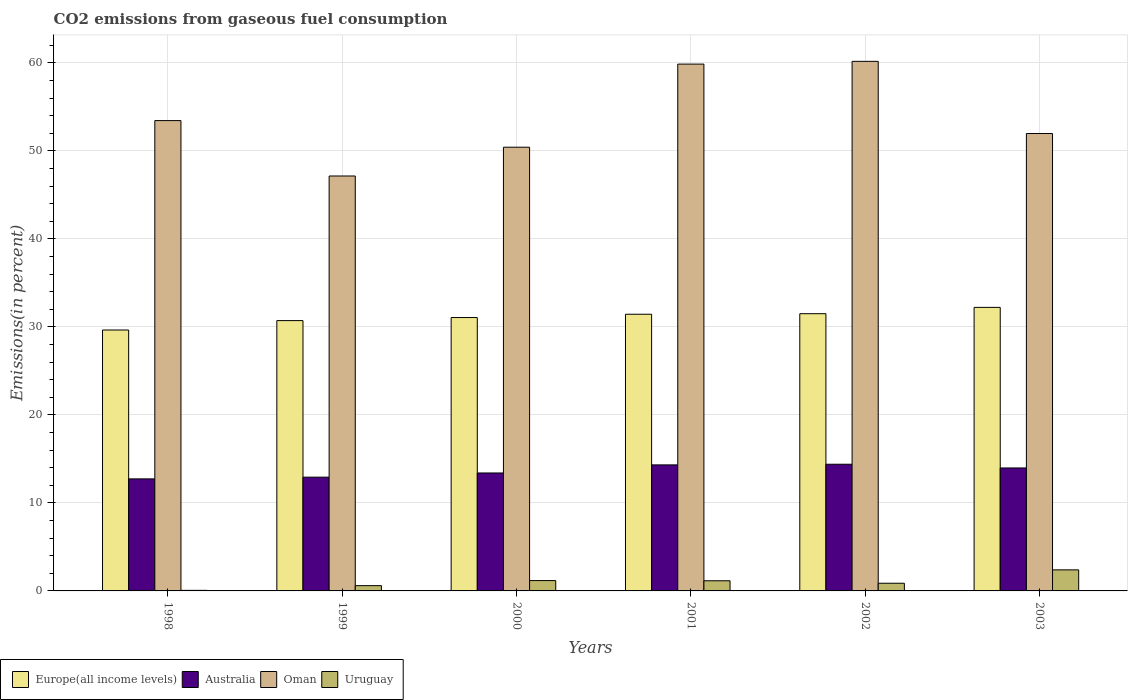What is the total CO2 emitted in Uruguay in 1998?
Offer a very short reply. 0.06. Across all years, what is the maximum total CO2 emitted in Uruguay?
Give a very brief answer. 2.39. Across all years, what is the minimum total CO2 emitted in Europe(all income levels)?
Your answer should be very brief. 29.64. In which year was the total CO2 emitted in Oman maximum?
Offer a terse response. 2002. What is the total total CO2 emitted in Oman in the graph?
Give a very brief answer. 322.96. What is the difference between the total CO2 emitted in Australia in 2001 and that in 2003?
Give a very brief answer. 0.35. What is the difference between the total CO2 emitted in Europe(all income levels) in 1998 and the total CO2 emitted in Uruguay in 2002?
Ensure brevity in your answer.  28.77. What is the average total CO2 emitted in Europe(all income levels) per year?
Your answer should be compact. 31.09. In the year 2001, what is the difference between the total CO2 emitted in Europe(all income levels) and total CO2 emitted in Uruguay?
Keep it short and to the point. 30.28. In how many years, is the total CO2 emitted in Oman greater than 38 %?
Ensure brevity in your answer.  6. What is the ratio of the total CO2 emitted in Australia in 2001 to that in 2003?
Ensure brevity in your answer.  1.03. What is the difference between the highest and the second highest total CO2 emitted in Uruguay?
Keep it short and to the point. 1.22. What is the difference between the highest and the lowest total CO2 emitted in Oman?
Provide a succinct answer. 13.02. Is the sum of the total CO2 emitted in Oman in 1999 and 2003 greater than the maximum total CO2 emitted in Europe(all income levels) across all years?
Offer a very short reply. Yes. Is it the case that in every year, the sum of the total CO2 emitted in Oman and total CO2 emitted in Europe(all income levels) is greater than the sum of total CO2 emitted in Australia and total CO2 emitted in Uruguay?
Your answer should be compact. Yes. What does the 1st bar from the left in 2003 represents?
Provide a short and direct response. Europe(all income levels). What does the 3rd bar from the right in 2002 represents?
Make the answer very short. Australia. What is the difference between two consecutive major ticks on the Y-axis?
Provide a short and direct response. 10. Are the values on the major ticks of Y-axis written in scientific E-notation?
Your answer should be compact. No. Does the graph contain any zero values?
Give a very brief answer. No. Where does the legend appear in the graph?
Make the answer very short. Bottom left. How many legend labels are there?
Provide a short and direct response. 4. What is the title of the graph?
Offer a very short reply. CO2 emissions from gaseous fuel consumption. What is the label or title of the X-axis?
Offer a terse response. Years. What is the label or title of the Y-axis?
Give a very brief answer. Emissions(in percent). What is the Emissions(in percent) in Europe(all income levels) in 1998?
Make the answer very short. 29.64. What is the Emissions(in percent) of Australia in 1998?
Give a very brief answer. 12.73. What is the Emissions(in percent) in Oman in 1998?
Your answer should be very brief. 53.43. What is the Emissions(in percent) of Uruguay in 1998?
Offer a very short reply. 0.06. What is the Emissions(in percent) in Europe(all income levels) in 1999?
Your answer should be very brief. 30.71. What is the Emissions(in percent) in Australia in 1999?
Provide a succinct answer. 12.92. What is the Emissions(in percent) of Oman in 1999?
Your response must be concise. 47.14. What is the Emissions(in percent) in Uruguay in 1999?
Make the answer very short. 0.6. What is the Emissions(in percent) in Europe(all income levels) in 2000?
Provide a short and direct response. 31.06. What is the Emissions(in percent) of Australia in 2000?
Offer a terse response. 13.4. What is the Emissions(in percent) in Oman in 2000?
Your answer should be compact. 50.41. What is the Emissions(in percent) of Uruguay in 2000?
Provide a short and direct response. 1.17. What is the Emissions(in percent) of Europe(all income levels) in 2001?
Ensure brevity in your answer.  31.43. What is the Emissions(in percent) of Australia in 2001?
Keep it short and to the point. 14.32. What is the Emissions(in percent) in Oman in 2001?
Make the answer very short. 59.85. What is the Emissions(in percent) of Uruguay in 2001?
Ensure brevity in your answer.  1.15. What is the Emissions(in percent) of Europe(all income levels) in 2002?
Make the answer very short. 31.5. What is the Emissions(in percent) in Australia in 2002?
Offer a terse response. 14.39. What is the Emissions(in percent) in Oman in 2002?
Give a very brief answer. 60.16. What is the Emissions(in percent) in Uruguay in 2002?
Your answer should be very brief. 0.87. What is the Emissions(in percent) in Europe(all income levels) in 2003?
Your answer should be compact. 32.21. What is the Emissions(in percent) of Australia in 2003?
Your answer should be compact. 13.97. What is the Emissions(in percent) in Oman in 2003?
Your response must be concise. 51.96. What is the Emissions(in percent) in Uruguay in 2003?
Offer a very short reply. 2.39. Across all years, what is the maximum Emissions(in percent) in Europe(all income levels)?
Offer a very short reply. 32.21. Across all years, what is the maximum Emissions(in percent) in Australia?
Give a very brief answer. 14.39. Across all years, what is the maximum Emissions(in percent) of Oman?
Provide a short and direct response. 60.16. Across all years, what is the maximum Emissions(in percent) in Uruguay?
Ensure brevity in your answer.  2.39. Across all years, what is the minimum Emissions(in percent) of Europe(all income levels)?
Your answer should be very brief. 29.64. Across all years, what is the minimum Emissions(in percent) in Australia?
Provide a short and direct response. 12.73. Across all years, what is the minimum Emissions(in percent) of Oman?
Offer a terse response. 47.14. Across all years, what is the minimum Emissions(in percent) of Uruguay?
Give a very brief answer. 0.06. What is the total Emissions(in percent) of Europe(all income levels) in the graph?
Your answer should be very brief. 186.55. What is the total Emissions(in percent) of Australia in the graph?
Provide a short and direct response. 81.73. What is the total Emissions(in percent) of Oman in the graph?
Make the answer very short. 322.96. What is the total Emissions(in percent) in Uruguay in the graph?
Provide a short and direct response. 6.26. What is the difference between the Emissions(in percent) in Europe(all income levels) in 1998 and that in 1999?
Your answer should be compact. -1.07. What is the difference between the Emissions(in percent) in Australia in 1998 and that in 1999?
Provide a succinct answer. -0.19. What is the difference between the Emissions(in percent) of Oman in 1998 and that in 1999?
Give a very brief answer. 6.29. What is the difference between the Emissions(in percent) in Uruguay in 1998 and that in 1999?
Provide a succinct answer. -0.54. What is the difference between the Emissions(in percent) in Europe(all income levels) in 1998 and that in 2000?
Keep it short and to the point. -1.42. What is the difference between the Emissions(in percent) of Australia in 1998 and that in 2000?
Offer a terse response. -0.67. What is the difference between the Emissions(in percent) in Oman in 1998 and that in 2000?
Provide a short and direct response. 3.02. What is the difference between the Emissions(in percent) of Uruguay in 1998 and that in 2000?
Provide a succinct answer. -1.11. What is the difference between the Emissions(in percent) of Europe(all income levels) in 1998 and that in 2001?
Offer a very short reply. -1.79. What is the difference between the Emissions(in percent) of Australia in 1998 and that in 2001?
Provide a succinct answer. -1.59. What is the difference between the Emissions(in percent) in Oman in 1998 and that in 2001?
Provide a short and direct response. -6.42. What is the difference between the Emissions(in percent) of Uruguay in 1998 and that in 2001?
Provide a short and direct response. -1.09. What is the difference between the Emissions(in percent) of Europe(all income levels) in 1998 and that in 2002?
Your answer should be compact. -1.85. What is the difference between the Emissions(in percent) in Australia in 1998 and that in 2002?
Offer a terse response. -1.66. What is the difference between the Emissions(in percent) in Oman in 1998 and that in 2002?
Offer a very short reply. -6.73. What is the difference between the Emissions(in percent) in Uruguay in 1998 and that in 2002?
Offer a very short reply. -0.81. What is the difference between the Emissions(in percent) of Europe(all income levels) in 1998 and that in 2003?
Offer a terse response. -2.57. What is the difference between the Emissions(in percent) of Australia in 1998 and that in 2003?
Your answer should be compact. -1.24. What is the difference between the Emissions(in percent) in Oman in 1998 and that in 2003?
Give a very brief answer. 1.47. What is the difference between the Emissions(in percent) in Uruguay in 1998 and that in 2003?
Give a very brief answer. -2.33. What is the difference between the Emissions(in percent) in Europe(all income levels) in 1999 and that in 2000?
Give a very brief answer. -0.35. What is the difference between the Emissions(in percent) in Australia in 1999 and that in 2000?
Ensure brevity in your answer.  -0.48. What is the difference between the Emissions(in percent) in Oman in 1999 and that in 2000?
Give a very brief answer. -3.27. What is the difference between the Emissions(in percent) of Uruguay in 1999 and that in 2000?
Ensure brevity in your answer.  -0.58. What is the difference between the Emissions(in percent) in Europe(all income levels) in 1999 and that in 2001?
Make the answer very short. -0.72. What is the difference between the Emissions(in percent) of Australia in 1999 and that in 2001?
Provide a short and direct response. -1.4. What is the difference between the Emissions(in percent) of Oman in 1999 and that in 2001?
Give a very brief answer. -12.71. What is the difference between the Emissions(in percent) of Uruguay in 1999 and that in 2001?
Keep it short and to the point. -0.55. What is the difference between the Emissions(in percent) in Europe(all income levels) in 1999 and that in 2002?
Give a very brief answer. -0.78. What is the difference between the Emissions(in percent) of Australia in 1999 and that in 2002?
Provide a short and direct response. -1.47. What is the difference between the Emissions(in percent) of Oman in 1999 and that in 2002?
Offer a very short reply. -13.02. What is the difference between the Emissions(in percent) of Uruguay in 1999 and that in 2002?
Offer a very short reply. -0.27. What is the difference between the Emissions(in percent) in Europe(all income levels) in 1999 and that in 2003?
Your answer should be compact. -1.5. What is the difference between the Emissions(in percent) in Australia in 1999 and that in 2003?
Ensure brevity in your answer.  -1.05. What is the difference between the Emissions(in percent) in Oman in 1999 and that in 2003?
Offer a very short reply. -4.82. What is the difference between the Emissions(in percent) in Uruguay in 1999 and that in 2003?
Provide a short and direct response. -1.79. What is the difference between the Emissions(in percent) in Europe(all income levels) in 2000 and that in 2001?
Your response must be concise. -0.37. What is the difference between the Emissions(in percent) of Australia in 2000 and that in 2001?
Your response must be concise. -0.92. What is the difference between the Emissions(in percent) of Oman in 2000 and that in 2001?
Offer a very short reply. -9.44. What is the difference between the Emissions(in percent) in Uruguay in 2000 and that in 2001?
Keep it short and to the point. 0.02. What is the difference between the Emissions(in percent) in Europe(all income levels) in 2000 and that in 2002?
Offer a terse response. -0.44. What is the difference between the Emissions(in percent) of Australia in 2000 and that in 2002?
Your response must be concise. -0.99. What is the difference between the Emissions(in percent) of Oman in 2000 and that in 2002?
Your answer should be very brief. -9.75. What is the difference between the Emissions(in percent) of Uruguay in 2000 and that in 2002?
Give a very brief answer. 0.3. What is the difference between the Emissions(in percent) of Europe(all income levels) in 2000 and that in 2003?
Ensure brevity in your answer.  -1.15. What is the difference between the Emissions(in percent) in Australia in 2000 and that in 2003?
Ensure brevity in your answer.  -0.57. What is the difference between the Emissions(in percent) in Oman in 2000 and that in 2003?
Give a very brief answer. -1.55. What is the difference between the Emissions(in percent) of Uruguay in 2000 and that in 2003?
Provide a succinct answer. -1.22. What is the difference between the Emissions(in percent) in Europe(all income levels) in 2001 and that in 2002?
Ensure brevity in your answer.  -0.06. What is the difference between the Emissions(in percent) in Australia in 2001 and that in 2002?
Your response must be concise. -0.07. What is the difference between the Emissions(in percent) in Oman in 2001 and that in 2002?
Ensure brevity in your answer.  -0.31. What is the difference between the Emissions(in percent) of Uruguay in 2001 and that in 2002?
Ensure brevity in your answer.  0.28. What is the difference between the Emissions(in percent) of Europe(all income levels) in 2001 and that in 2003?
Give a very brief answer. -0.78. What is the difference between the Emissions(in percent) of Australia in 2001 and that in 2003?
Give a very brief answer. 0.35. What is the difference between the Emissions(in percent) of Oman in 2001 and that in 2003?
Your response must be concise. 7.89. What is the difference between the Emissions(in percent) in Uruguay in 2001 and that in 2003?
Your answer should be very brief. -1.24. What is the difference between the Emissions(in percent) in Europe(all income levels) in 2002 and that in 2003?
Keep it short and to the point. -0.72. What is the difference between the Emissions(in percent) of Australia in 2002 and that in 2003?
Keep it short and to the point. 0.42. What is the difference between the Emissions(in percent) in Oman in 2002 and that in 2003?
Provide a succinct answer. 8.2. What is the difference between the Emissions(in percent) of Uruguay in 2002 and that in 2003?
Provide a succinct answer. -1.52. What is the difference between the Emissions(in percent) of Europe(all income levels) in 1998 and the Emissions(in percent) of Australia in 1999?
Offer a very short reply. 16.72. What is the difference between the Emissions(in percent) of Europe(all income levels) in 1998 and the Emissions(in percent) of Oman in 1999?
Make the answer very short. -17.5. What is the difference between the Emissions(in percent) of Europe(all income levels) in 1998 and the Emissions(in percent) of Uruguay in 1999?
Give a very brief answer. 29.04. What is the difference between the Emissions(in percent) of Australia in 1998 and the Emissions(in percent) of Oman in 1999?
Your response must be concise. -34.41. What is the difference between the Emissions(in percent) of Australia in 1998 and the Emissions(in percent) of Uruguay in 1999?
Keep it short and to the point. 12.13. What is the difference between the Emissions(in percent) of Oman in 1998 and the Emissions(in percent) of Uruguay in 1999?
Your answer should be very brief. 52.83. What is the difference between the Emissions(in percent) in Europe(all income levels) in 1998 and the Emissions(in percent) in Australia in 2000?
Offer a terse response. 16.24. What is the difference between the Emissions(in percent) in Europe(all income levels) in 1998 and the Emissions(in percent) in Oman in 2000?
Ensure brevity in your answer.  -20.77. What is the difference between the Emissions(in percent) of Europe(all income levels) in 1998 and the Emissions(in percent) of Uruguay in 2000?
Keep it short and to the point. 28.47. What is the difference between the Emissions(in percent) of Australia in 1998 and the Emissions(in percent) of Oman in 2000?
Provide a short and direct response. -37.68. What is the difference between the Emissions(in percent) in Australia in 1998 and the Emissions(in percent) in Uruguay in 2000?
Your answer should be very brief. 11.55. What is the difference between the Emissions(in percent) of Oman in 1998 and the Emissions(in percent) of Uruguay in 2000?
Give a very brief answer. 52.26. What is the difference between the Emissions(in percent) of Europe(all income levels) in 1998 and the Emissions(in percent) of Australia in 2001?
Your answer should be very brief. 15.32. What is the difference between the Emissions(in percent) of Europe(all income levels) in 1998 and the Emissions(in percent) of Oman in 2001?
Ensure brevity in your answer.  -30.21. What is the difference between the Emissions(in percent) in Europe(all income levels) in 1998 and the Emissions(in percent) in Uruguay in 2001?
Your response must be concise. 28.49. What is the difference between the Emissions(in percent) of Australia in 1998 and the Emissions(in percent) of Oman in 2001?
Ensure brevity in your answer.  -47.12. What is the difference between the Emissions(in percent) of Australia in 1998 and the Emissions(in percent) of Uruguay in 2001?
Offer a terse response. 11.58. What is the difference between the Emissions(in percent) of Oman in 1998 and the Emissions(in percent) of Uruguay in 2001?
Provide a short and direct response. 52.28. What is the difference between the Emissions(in percent) of Europe(all income levels) in 1998 and the Emissions(in percent) of Australia in 2002?
Your response must be concise. 15.25. What is the difference between the Emissions(in percent) in Europe(all income levels) in 1998 and the Emissions(in percent) in Oman in 2002?
Ensure brevity in your answer.  -30.52. What is the difference between the Emissions(in percent) of Europe(all income levels) in 1998 and the Emissions(in percent) of Uruguay in 2002?
Your answer should be compact. 28.77. What is the difference between the Emissions(in percent) in Australia in 1998 and the Emissions(in percent) in Oman in 2002?
Provide a short and direct response. -47.44. What is the difference between the Emissions(in percent) in Australia in 1998 and the Emissions(in percent) in Uruguay in 2002?
Give a very brief answer. 11.86. What is the difference between the Emissions(in percent) of Oman in 1998 and the Emissions(in percent) of Uruguay in 2002?
Your answer should be very brief. 52.56. What is the difference between the Emissions(in percent) of Europe(all income levels) in 1998 and the Emissions(in percent) of Australia in 2003?
Give a very brief answer. 15.67. What is the difference between the Emissions(in percent) of Europe(all income levels) in 1998 and the Emissions(in percent) of Oman in 2003?
Ensure brevity in your answer.  -22.32. What is the difference between the Emissions(in percent) in Europe(all income levels) in 1998 and the Emissions(in percent) in Uruguay in 2003?
Ensure brevity in your answer.  27.25. What is the difference between the Emissions(in percent) of Australia in 1998 and the Emissions(in percent) of Oman in 2003?
Your answer should be compact. -39.24. What is the difference between the Emissions(in percent) of Australia in 1998 and the Emissions(in percent) of Uruguay in 2003?
Provide a short and direct response. 10.34. What is the difference between the Emissions(in percent) in Oman in 1998 and the Emissions(in percent) in Uruguay in 2003?
Your response must be concise. 51.04. What is the difference between the Emissions(in percent) in Europe(all income levels) in 1999 and the Emissions(in percent) in Australia in 2000?
Provide a succinct answer. 17.31. What is the difference between the Emissions(in percent) in Europe(all income levels) in 1999 and the Emissions(in percent) in Oman in 2000?
Ensure brevity in your answer.  -19.7. What is the difference between the Emissions(in percent) of Europe(all income levels) in 1999 and the Emissions(in percent) of Uruguay in 2000?
Provide a succinct answer. 29.54. What is the difference between the Emissions(in percent) in Australia in 1999 and the Emissions(in percent) in Oman in 2000?
Provide a succinct answer. -37.49. What is the difference between the Emissions(in percent) in Australia in 1999 and the Emissions(in percent) in Uruguay in 2000?
Provide a succinct answer. 11.75. What is the difference between the Emissions(in percent) in Oman in 1999 and the Emissions(in percent) in Uruguay in 2000?
Provide a succinct answer. 45.97. What is the difference between the Emissions(in percent) in Europe(all income levels) in 1999 and the Emissions(in percent) in Australia in 2001?
Provide a succinct answer. 16.39. What is the difference between the Emissions(in percent) in Europe(all income levels) in 1999 and the Emissions(in percent) in Oman in 2001?
Keep it short and to the point. -29.14. What is the difference between the Emissions(in percent) in Europe(all income levels) in 1999 and the Emissions(in percent) in Uruguay in 2001?
Make the answer very short. 29.56. What is the difference between the Emissions(in percent) of Australia in 1999 and the Emissions(in percent) of Oman in 2001?
Offer a very short reply. -46.93. What is the difference between the Emissions(in percent) of Australia in 1999 and the Emissions(in percent) of Uruguay in 2001?
Your response must be concise. 11.77. What is the difference between the Emissions(in percent) of Oman in 1999 and the Emissions(in percent) of Uruguay in 2001?
Offer a terse response. 45.99. What is the difference between the Emissions(in percent) of Europe(all income levels) in 1999 and the Emissions(in percent) of Australia in 2002?
Offer a very short reply. 16.32. What is the difference between the Emissions(in percent) of Europe(all income levels) in 1999 and the Emissions(in percent) of Oman in 2002?
Ensure brevity in your answer.  -29.45. What is the difference between the Emissions(in percent) of Europe(all income levels) in 1999 and the Emissions(in percent) of Uruguay in 2002?
Your answer should be compact. 29.84. What is the difference between the Emissions(in percent) in Australia in 1999 and the Emissions(in percent) in Oman in 2002?
Offer a very short reply. -47.24. What is the difference between the Emissions(in percent) of Australia in 1999 and the Emissions(in percent) of Uruguay in 2002?
Give a very brief answer. 12.05. What is the difference between the Emissions(in percent) of Oman in 1999 and the Emissions(in percent) of Uruguay in 2002?
Keep it short and to the point. 46.27. What is the difference between the Emissions(in percent) in Europe(all income levels) in 1999 and the Emissions(in percent) in Australia in 2003?
Offer a very short reply. 16.74. What is the difference between the Emissions(in percent) of Europe(all income levels) in 1999 and the Emissions(in percent) of Oman in 2003?
Offer a very short reply. -21.25. What is the difference between the Emissions(in percent) of Europe(all income levels) in 1999 and the Emissions(in percent) of Uruguay in 2003?
Keep it short and to the point. 28.32. What is the difference between the Emissions(in percent) of Australia in 1999 and the Emissions(in percent) of Oman in 2003?
Give a very brief answer. -39.04. What is the difference between the Emissions(in percent) of Australia in 1999 and the Emissions(in percent) of Uruguay in 2003?
Provide a succinct answer. 10.53. What is the difference between the Emissions(in percent) in Oman in 1999 and the Emissions(in percent) in Uruguay in 2003?
Offer a terse response. 44.75. What is the difference between the Emissions(in percent) of Europe(all income levels) in 2000 and the Emissions(in percent) of Australia in 2001?
Your response must be concise. 16.74. What is the difference between the Emissions(in percent) of Europe(all income levels) in 2000 and the Emissions(in percent) of Oman in 2001?
Your response must be concise. -28.79. What is the difference between the Emissions(in percent) in Europe(all income levels) in 2000 and the Emissions(in percent) in Uruguay in 2001?
Your answer should be compact. 29.91. What is the difference between the Emissions(in percent) of Australia in 2000 and the Emissions(in percent) of Oman in 2001?
Your answer should be compact. -46.45. What is the difference between the Emissions(in percent) in Australia in 2000 and the Emissions(in percent) in Uruguay in 2001?
Your answer should be compact. 12.25. What is the difference between the Emissions(in percent) in Oman in 2000 and the Emissions(in percent) in Uruguay in 2001?
Make the answer very short. 49.26. What is the difference between the Emissions(in percent) of Europe(all income levels) in 2000 and the Emissions(in percent) of Australia in 2002?
Make the answer very short. 16.67. What is the difference between the Emissions(in percent) of Europe(all income levels) in 2000 and the Emissions(in percent) of Oman in 2002?
Your answer should be very brief. -29.11. What is the difference between the Emissions(in percent) in Europe(all income levels) in 2000 and the Emissions(in percent) in Uruguay in 2002?
Keep it short and to the point. 30.19. What is the difference between the Emissions(in percent) in Australia in 2000 and the Emissions(in percent) in Oman in 2002?
Make the answer very short. -46.77. What is the difference between the Emissions(in percent) of Australia in 2000 and the Emissions(in percent) of Uruguay in 2002?
Give a very brief answer. 12.53. What is the difference between the Emissions(in percent) in Oman in 2000 and the Emissions(in percent) in Uruguay in 2002?
Provide a succinct answer. 49.54. What is the difference between the Emissions(in percent) in Europe(all income levels) in 2000 and the Emissions(in percent) in Australia in 2003?
Your response must be concise. 17.09. What is the difference between the Emissions(in percent) of Europe(all income levels) in 2000 and the Emissions(in percent) of Oman in 2003?
Provide a succinct answer. -20.91. What is the difference between the Emissions(in percent) of Europe(all income levels) in 2000 and the Emissions(in percent) of Uruguay in 2003?
Offer a very short reply. 28.67. What is the difference between the Emissions(in percent) of Australia in 2000 and the Emissions(in percent) of Oman in 2003?
Keep it short and to the point. -38.57. What is the difference between the Emissions(in percent) in Australia in 2000 and the Emissions(in percent) in Uruguay in 2003?
Offer a very short reply. 11.01. What is the difference between the Emissions(in percent) of Oman in 2000 and the Emissions(in percent) of Uruguay in 2003?
Ensure brevity in your answer.  48.02. What is the difference between the Emissions(in percent) of Europe(all income levels) in 2001 and the Emissions(in percent) of Australia in 2002?
Your answer should be very brief. 17.04. What is the difference between the Emissions(in percent) in Europe(all income levels) in 2001 and the Emissions(in percent) in Oman in 2002?
Offer a very short reply. -28.73. What is the difference between the Emissions(in percent) in Europe(all income levels) in 2001 and the Emissions(in percent) in Uruguay in 2002?
Make the answer very short. 30.56. What is the difference between the Emissions(in percent) of Australia in 2001 and the Emissions(in percent) of Oman in 2002?
Your answer should be compact. -45.84. What is the difference between the Emissions(in percent) of Australia in 2001 and the Emissions(in percent) of Uruguay in 2002?
Ensure brevity in your answer.  13.45. What is the difference between the Emissions(in percent) of Oman in 2001 and the Emissions(in percent) of Uruguay in 2002?
Your answer should be compact. 58.98. What is the difference between the Emissions(in percent) in Europe(all income levels) in 2001 and the Emissions(in percent) in Australia in 2003?
Your answer should be compact. 17.46. What is the difference between the Emissions(in percent) in Europe(all income levels) in 2001 and the Emissions(in percent) in Oman in 2003?
Your answer should be compact. -20.53. What is the difference between the Emissions(in percent) in Europe(all income levels) in 2001 and the Emissions(in percent) in Uruguay in 2003?
Offer a very short reply. 29.04. What is the difference between the Emissions(in percent) of Australia in 2001 and the Emissions(in percent) of Oman in 2003?
Offer a very short reply. -37.65. What is the difference between the Emissions(in percent) of Australia in 2001 and the Emissions(in percent) of Uruguay in 2003?
Your answer should be very brief. 11.93. What is the difference between the Emissions(in percent) in Oman in 2001 and the Emissions(in percent) in Uruguay in 2003?
Your response must be concise. 57.46. What is the difference between the Emissions(in percent) in Europe(all income levels) in 2002 and the Emissions(in percent) in Australia in 2003?
Provide a succinct answer. 17.53. What is the difference between the Emissions(in percent) in Europe(all income levels) in 2002 and the Emissions(in percent) in Oman in 2003?
Your answer should be very brief. -20.47. What is the difference between the Emissions(in percent) in Europe(all income levels) in 2002 and the Emissions(in percent) in Uruguay in 2003?
Your response must be concise. 29.1. What is the difference between the Emissions(in percent) of Australia in 2002 and the Emissions(in percent) of Oman in 2003?
Your answer should be very brief. -37.57. What is the difference between the Emissions(in percent) in Oman in 2002 and the Emissions(in percent) in Uruguay in 2003?
Ensure brevity in your answer.  57.77. What is the average Emissions(in percent) of Europe(all income levels) per year?
Give a very brief answer. 31.09. What is the average Emissions(in percent) of Australia per year?
Ensure brevity in your answer.  13.62. What is the average Emissions(in percent) in Oman per year?
Provide a short and direct response. 53.83. What is the average Emissions(in percent) of Uruguay per year?
Ensure brevity in your answer.  1.04. In the year 1998, what is the difference between the Emissions(in percent) in Europe(all income levels) and Emissions(in percent) in Australia?
Provide a short and direct response. 16.91. In the year 1998, what is the difference between the Emissions(in percent) of Europe(all income levels) and Emissions(in percent) of Oman?
Offer a very short reply. -23.79. In the year 1998, what is the difference between the Emissions(in percent) in Europe(all income levels) and Emissions(in percent) in Uruguay?
Offer a terse response. 29.58. In the year 1998, what is the difference between the Emissions(in percent) in Australia and Emissions(in percent) in Oman?
Give a very brief answer. -40.7. In the year 1998, what is the difference between the Emissions(in percent) of Australia and Emissions(in percent) of Uruguay?
Offer a very short reply. 12.66. In the year 1998, what is the difference between the Emissions(in percent) of Oman and Emissions(in percent) of Uruguay?
Keep it short and to the point. 53.37. In the year 1999, what is the difference between the Emissions(in percent) in Europe(all income levels) and Emissions(in percent) in Australia?
Ensure brevity in your answer.  17.79. In the year 1999, what is the difference between the Emissions(in percent) in Europe(all income levels) and Emissions(in percent) in Oman?
Provide a succinct answer. -16.43. In the year 1999, what is the difference between the Emissions(in percent) in Europe(all income levels) and Emissions(in percent) in Uruguay?
Your answer should be compact. 30.11. In the year 1999, what is the difference between the Emissions(in percent) of Australia and Emissions(in percent) of Oman?
Provide a short and direct response. -34.22. In the year 1999, what is the difference between the Emissions(in percent) in Australia and Emissions(in percent) in Uruguay?
Provide a short and direct response. 12.32. In the year 1999, what is the difference between the Emissions(in percent) of Oman and Emissions(in percent) of Uruguay?
Ensure brevity in your answer.  46.54. In the year 2000, what is the difference between the Emissions(in percent) of Europe(all income levels) and Emissions(in percent) of Australia?
Make the answer very short. 17.66. In the year 2000, what is the difference between the Emissions(in percent) of Europe(all income levels) and Emissions(in percent) of Oman?
Ensure brevity in your answer.  -19.35. In the year 2000, what is the difference between the Emissions(in percent) in Europe(all income levels) and Emissions(in percent) in Uruguay?
Provide a short and direct response. 29.88. In the year 2000, what is the difference between the Emissions(in percent) in Australia and Emissions(in percent) in Oman?
Your answer should be compact. -37.01. In the year 2000, what is the difference between the Emissions(in percent) in Australia and Emissions(in percent) in Uruguay?
Provide a short and direct response. 12.22. In the year 2000, what is the difference between the Emissions(in percent) in Oman and Emissions(in percent) in Uruguay?
Keep it short and to the point. 49.24. In the year 2001, what is the difference between the Emissions(in percent) in Europe(all income levels) and Emissions(in percent) in Australia?
Keep it short and to the point. 17.11. In the year 2001, what is the difference between the Emissions(in percent) in Europe(all income levels) and Emissions(in percent) in Oman?
Keep it short and to the point. -28.42. In the year 2001, what is the difference between the Emissions(in percent) in Europe(all income levels) and Emissions(in percent) in Uruguay?
Your answer should be very brief. 30.28. In the year 2001, what is the difference between the Emissions(in percent) of Australia and Emissions(in percent) of Oman?
Provide a short and direct response. -45.53. In the year 2001, what is the difference between the Emissions(in percent) in Australia and Emissions(in percent) in Uruguay?
Provide a succinct answer. 13.17. In the year 2001, what is the difference between the Emissions(in percent) of Oman and Emissions(in percent) of Uruguay?
Your answer should be very brief. 58.7. In the year 2002, what is the difference between the Emissions(in percent) of Europe(all income levels) and Emissions(in percent) of Australia?
Give a very brief answer. 17.1. In the year 2002, what is the difference between the Emissions(in percent) in Europe(all income levels) and Emissions(in percent) in Oman?
Offer a very short reply. -28.67. In the year 2002, what is the difference between the Emissions(in percent) of Europe(all income levels) and Emissions(in percent) of Uruguay?
Ensure brevity in your answer.  30.62. In the year 2002, what is the difference between the Emissions(in percent) in Australia and Emissions(in percent) in Oman?
Your answer should be very brief. -45.77. In the year 2002, what is the difference between the Emissions(in percent) in Australia and Emissions(in percent) in Uruguay?
Provide a succinct answer. 13.52. In the year 2002, what is the difference between the Emissions(in percent) in Oman and Emissions(in percent) in Uruguay?
Make the answer very short. 59.29. In the year 2003, what is the difference between the Emissions(in percent) in Europe(all income levels) and Emissions(in percent) in Australia?
Your response must be concise. 18.24. In the year 2003, what is the difference between the Emissions(in percent) of Europe(all income levels) and Emissions(in percent) of Oman?
Offer a very short reply. -19.75. In the year 2003, what is the difference between the Emissions(in percent) in Europe(all income levels) and Emissions(in percent) in Uruguay?
Your answer should be compact. 29.82. In the year 2003, what is the difference between the Emissions(in percent) of Australia and Emissions(in percent) of Oman?
Give a very brief answer. -38. In the year 2003, what is the difference between the Emissions(in percent) in Australia and Emissions(in percent) in Uruguay?
Make the answer very short. 11.58. In the year 2003, what is the difference between the Emissions(in percent) of Oman and Emissions(in percent) of Uruguay?
Offer a terse response. 49.57. What is the ratio of the Emissions(in percent) of Europe(all income levels) in 1998 to that in 1999?
Keep it short and to the point. 0.97. What is the ratio of the Emissions(in percent) in Australia in 1998 to that in 1999?
Keep it short and to the point. 0.98. What is the ratio of the Emissions(in percent) of Oman in 1998 to that in 1999?
Offer a very short reply. 1.13. What is the ratio of the Emissions(in percent) in Uruguay in 1998 to that in 1999?
Offer a terse response. 0.11. What is the ratio of the Emissions(in percent) of Europe(all income levels) in 1998 to that in 2000?
Offer a terse response. 0.95. What is the ratio of the Emissions(in percent) in Australia in 1998 to that in 2000?
Give a very brief answer. 0.95. What is the ratio of the Emissions(in percent) of Oman in 1998 to that in 2000?
Ensure brevity in your answer.  1.06. What is the ratio of the Emissions(in percent) of Uruguay in 1998 to that in 2000?
Ensure brevity in your answer.  0.05. What is the ratio of the Emissions(in percent) in Europe(all income levels) in 1998 to that in 2001?
Provide a succinct answer. 0.94. What is the ratio of the Emissions(in percent) of Australia in 1998 to that in 2001?
Provide a succinct answer. 0.89. What is the ratio of the Emissions(in percent) of Oman in 1998 to that in 2001?
Your answer should be compact. 0.89. What is the ratio of the Emissions(in percent) of Uruguay in 1998 to that in 2001?
Give a very brief answer. 0.06. What is the ratio of the Emissions(in percent) of Australia in 1998 to that in 2002?
Your answer should be very brief. 0.88. What is the ratio of the Emissions(in percent) in Oman in 1998 to that in 2002?
Your answer should be very brief. 0.89. What is the ratio of the Emissions(in percent) of Uruguay in 1998 to that in 2002?
Keep it short and to the point. 0.07. What is the ratio of the Emissions(in percent) in Europe(all income levels) in 1998 to that in 2003?
Ensure brevity in your answer.  0.92. What is the ratio of the Emissions(in percent) in Australia in 1998 to that in 2003?
Give a very brief answer. 0.91. What is the ratio of the Emissions(in percent) of Oman in 1998 to that in 2003?
Provide a short and direct response. 1.03. What is the ratio of the Emissions(in percent) of Uruguay in 1998 to that in 2003?
Give a very brief answer. 0.03. What is the ratio of the Emissions(in percent) of Europe(all income levels) in 1999 to that in 2000?
Offer a terse response. 0.99. What is the ratio of the Emissions(in percent) in Australia in 1999 to that in 2000?
Your answer should be very brief. 0.96. What is the ratio of the Emissions(in percent) in Oman in 1999 to that in 2000?
Make the answer very short. 0.94. What is the ratio of the Emissions(in percent) in Uruguay in 1999 to that in 2000?
Ensure brevity in your answer.  0.51. What is the ratio of the Emissions(in percent) in Australia in 1999 to that in 2001?
Make the answer very short. 0.9. What is the ratio of the Emissions(in percent) in Oman in 1999 to that in 2001?
Your response must be concise. 0.79. What is the ratio of the Emissions(in percent) of Uruguay in 1999 to that in 2001?
Make the answer very short. 0.52. What is the ratio of the Emissions(in percent) of Europe(all income levels) in 1999 to that in 2002?
Ensure brevity in your answer.  0.98. What is the ratio of the Emissions(in percent) in Australia in 1999 to that in 2002?
Make the answer very short. 0.9. What is the ratio of the Emissions(in percent) in Oman in 1999 to that in 2002?
Your answer should be compact. 0.78. What is the ratio of the Emissions(in percent) of Uruguay in 1999 to that in 2002?
Ensure brevity in your answer.  0.69. What is the ratio of the Emissions(in percent) in Europe(all income levels) in 1999 to that in 2003?
Your answer should be very brief. 0.95. What is the ratio of the Emissions(in percent) in Australia in 1999 to that in 2003?
Ensure brevity in your answer.  0.93. What is the ratio of the Emissions(in percent) in Oman in 1999 to that in 2003?
Give a very brief answer. 0.91. What is the ratio of the Emissions(in percent) in Uruguay in 1999 to that in 2003?
Offer a very short reply. 0.25. What is the ratio of the Emissions(in percent) in Europe(all income levels) in 2000 to that in 2001?
Provide a short and direct response. 0.99. What is the ratio of the Emissions(in percent) in Australia in 2000 to that in 2001?
Keep it short and to the point. 0.94. What is the ratio of the Emissions(in percent) of Oman in 2000 to that in 2001?
Offer a terse response. 0.84. What is the ratio of the Emissions(in percent) in Uruguay in 2000 to that in 2001?
Give a very brief answer. 1.02. What is the ratio of the Emissions(in percent) of Europe(all income levels) in 2000 to that in 2002?
Offer a very short reply. 0.99. What is the ratio of the Emissions(in percent) of Australia in 2000 to that in 2002?
Offer a very short reply. 0.93. What is the ratio of the Emissions(in percent) in Oman in 2000 to that in 2002?
Offer a terse response. 0.84. What is the ratio of the Emissions(in percent) of Uruguay in 2000 to that in 2002?
Offer a terse response. 1.35. What is the ratio of the Emissions(in percent) in Europe(all income levels) in 2000 to that in 2003?
Keep it short and to the point. 0.96. What is the ratio of the Emissions(in percent) of Australia in 2000 to that in 2003?
Your answer should be very brief. 0.96. What is the ratio of the Emissions(in percent) in Oman in 2000 to that in 2003?
Ensure brevity in your answer.  0.97. What is the ratio of the Emissions(in percent) of Uruguay in 2000 to that in 2003?
Provide a short and direct response. 0.49. What is the ratio of the Emissions(in percent) of Europe(all income levels) in 2001 to that in 2002?
Offer a very short reply. 1. What is the ratio of the Emissions(in percent) in Australia in 2001 to that in 2002?
Offer a terse response. 0.99. What is the ratio of the Emissions(in percent) of Oman in 2001 to that in 2002?
Keep it short and to the point. 0.99. What is the ratio of the Emissions(in percent) in Uruguay in 2001 to that in 2002?
Your answer should be compact. 1.32. What is the ratio of the Emissions(in percent) of Europe(all income levels) in 2001 to that in 2003?
Offer a terse response. 0.98. What is the ratio of the Emissions(in percent) in Australia in 2001 to that in 2003?
Make the answer very short. 1.03. What is the ratio of the Emissions(in percent) of Oman in 2001 to that in 2003?
Provide a short and direct response. 1.15. What is the ratio of the Emissions(in percent) of Uruguay in 2001 to that in 2003?
Provide a short and direct response. 0.48. What is the ratio of the Emissions(in percent) in Europe(all income levels) in 2002 to that in 2003?
Your response must be concise. 0.98. What is the ratio of the Emissions(in percent) in Australia in 2002 to that in 2003?
Provide a short and direct response. 1.03. What is the ratio of the Emissions(in percent) of Oman in 2002 to that in 2003?
Your answer should be very brief. 1.16. What is the ratio of the Emissions(in percent) in Uruguay in 2002 to that in 2003?
Provide a succinct answer. 0.36. What is the difference between the highest and the second highest Emissions(in percent) of Europe(all income levels)?
Your response must be concise. 0.72. What is the difference between the highest and the second highest Emissions(in percent) in Australia?
Ensure brevity in your answer.  0.07. What is the difference between the highest and the second highest Emissions(in percent) in Oman?
Offer a terse response. 0.31. What is the difference between the highest and the second highest Emissions(in percent) of Uruguay?
Your answer should be compact. 1.22. What is the difference between the highest and the lowest Emissions(in percent) of Europe(all income levels)?
Your response must be concise. 2.57. What is the difference between the highest and the lowest Emissions(in percent) in Australia?
Your response must be concise. 1.66. What is the difference between the highest and the lowest Emissions(in percent) of Oman?
Offer a terse response. 13.02. What is the difference between the highest and the lowest Emissions(in percent) of Uruguay?
Provide a succinct answer. 2.33. 